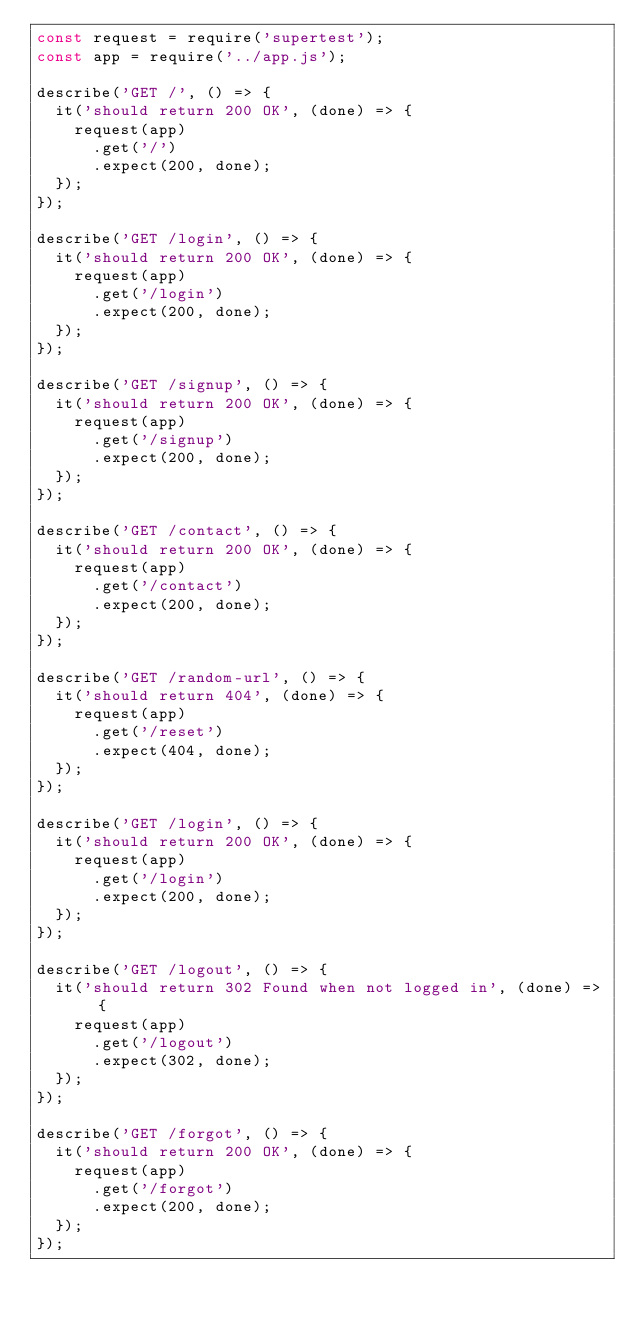<code> <loc_0><loc_0><loc_500><loc_500><_JavaScript_>const request = require('supertest');
const app = require('../app.js');

describe('GET /', () => {
  it('should return 200 OK', (done) => {
    request(app)
      .get('/')
      .expect(200, done);
  });
});

describe('GET /login', () => {
  it('should return 200 OK', (done) => {
    request(app)
      .get('/login')
      .expect(200, done);
  });
});

describe('GET /signup', () => {
  it('should return 200 OK', (done) => {
    request(app)
      .get('/signup')
      .expect(200, done);
  });
});

describe('GET /contact', () => {
  it('should return 200 OK', (done) => {
    request(app)
      .get('/contact')
      .expect(200, done);
  });
});

describe('GET /random-url', () => {
  it('should return 404', (done) => {
    request(app)
      .get('/reset')
      .expect(404, done);
  });
});

describe('GET /login', () => {
  it('should return 200 OK', (done) => {
    request(app)
      .get('/login')
      .expect(200, done);
  });
});

describe('GET /logout', () => {
  it('should return 302 Found when not logged in', (done) => {
    request(app)
      .get('/logout')
      .expect(302, done);
  });
});

describe('GET /forgot', () => {
  it('should return 200 OK', (done) => {
    request(app)
      .get('/forgot')
      .expect(200, done);
  });
});
</code> 